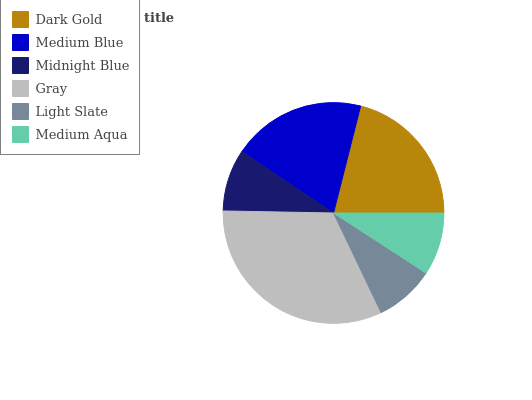Is Light Slate the minimum?
Answer yes or no. Yes. Is Gray the maximum?
Answer yes or no. Yes. Is Medium Blue the minimum?
Answer yes or no. No. Is Medium Blue the maximum?
Answer yes or no. No. Is Dark Gold greater than Medium Blue?
Answer yes or no. Yes. Is Medium Blue less than Dark Gold?
Answer yes or no. Yes. Is Medium Blue greater than Dark Gold?
Answer yes or no. No. Is Dark Gold less than Medium Blue?
Answer yes or no. No. Is Medium Blue the high median?
Answer yes or no. Yes. Is Medium Aqua the low median?
Answer yes or no. Yes. Is Medium Aqua the high median?
Answer yes or no. No. Is Medium Blue the low median?
Answer yes or no. No. 